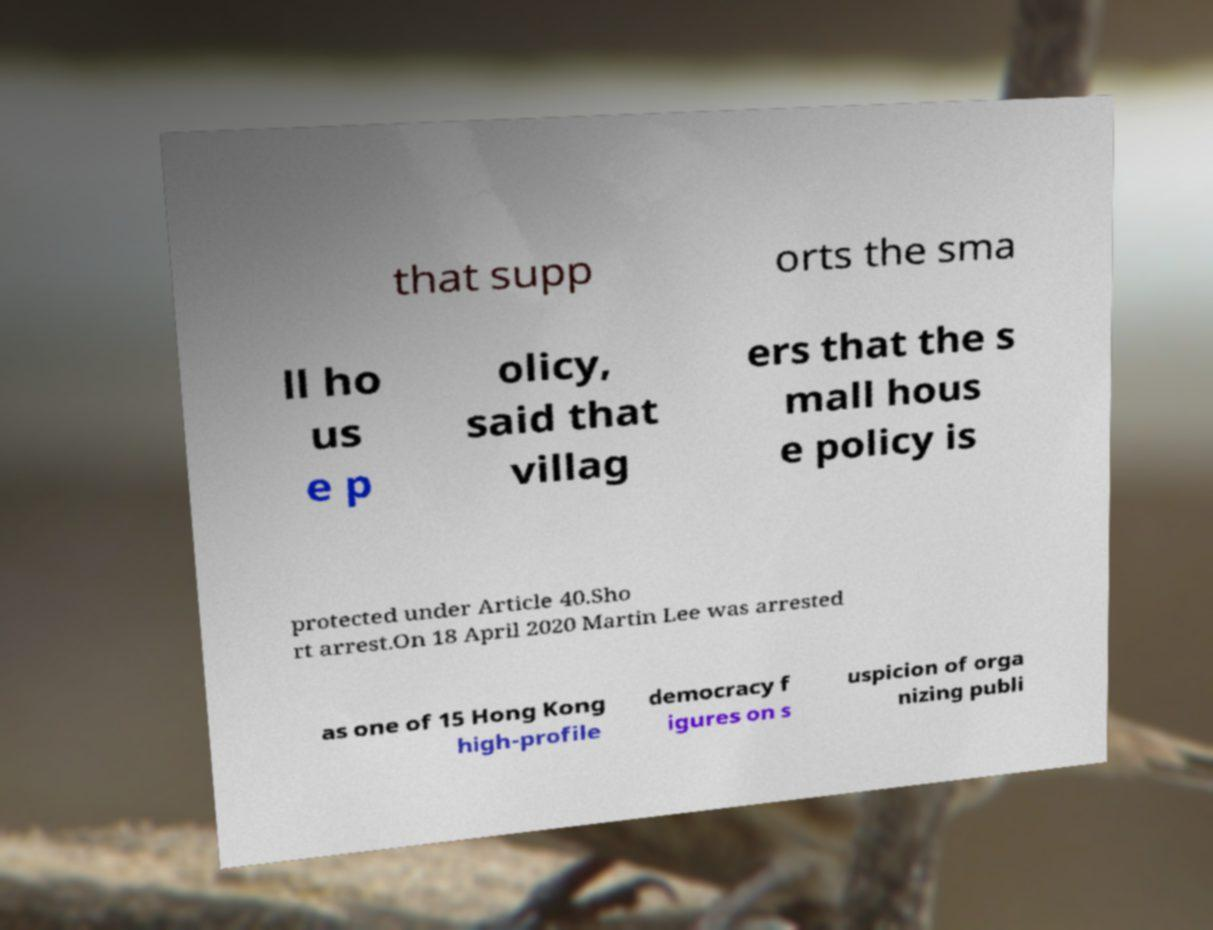What messages or text are displayed in this image? I need them in a readable, typed format. that supp orts the sma ll ho us e p olicy, said that villag ers that the s mall hous e policy is protected under Article 40.Sho rt arrest.On 18 April 2020 Martin Lee was arrested as one of 15 Hong Kong high-profile democracy f igures on s uspicion of orga nizing publi 